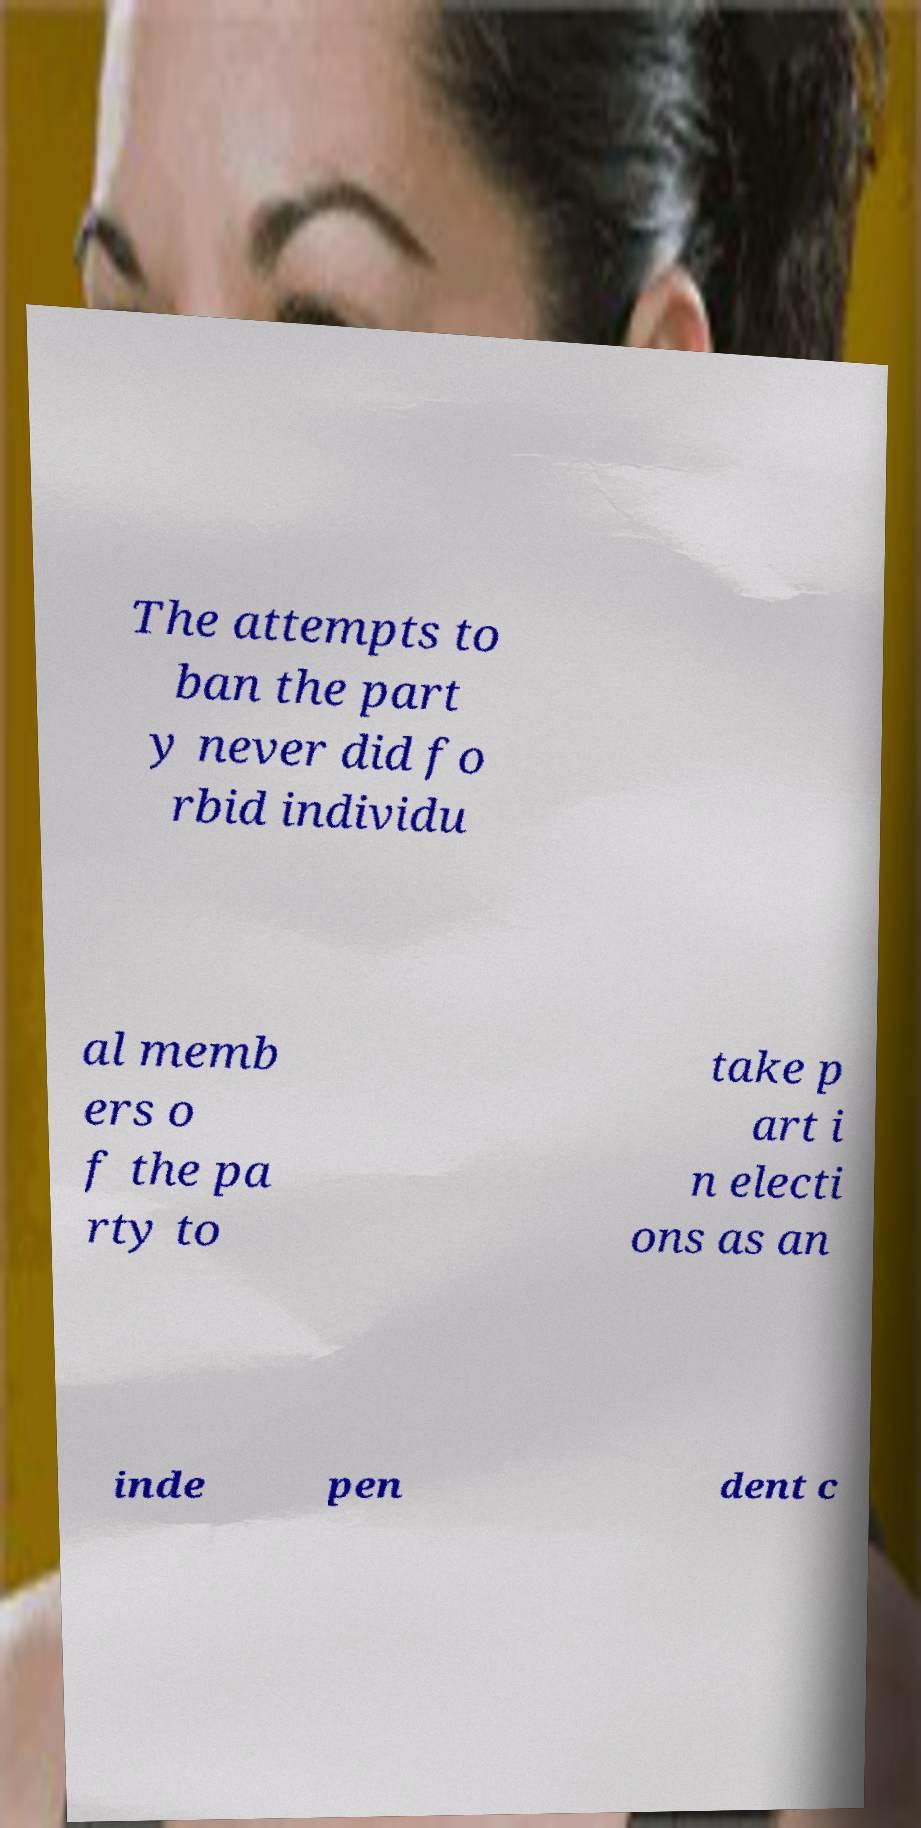Can you accurately transcribe the text from the provided image for me? The attempts to ban the part y never did fo rbid individu al memb ers o f the pa rty to take p art i n electi ons as an inde pen dent c 